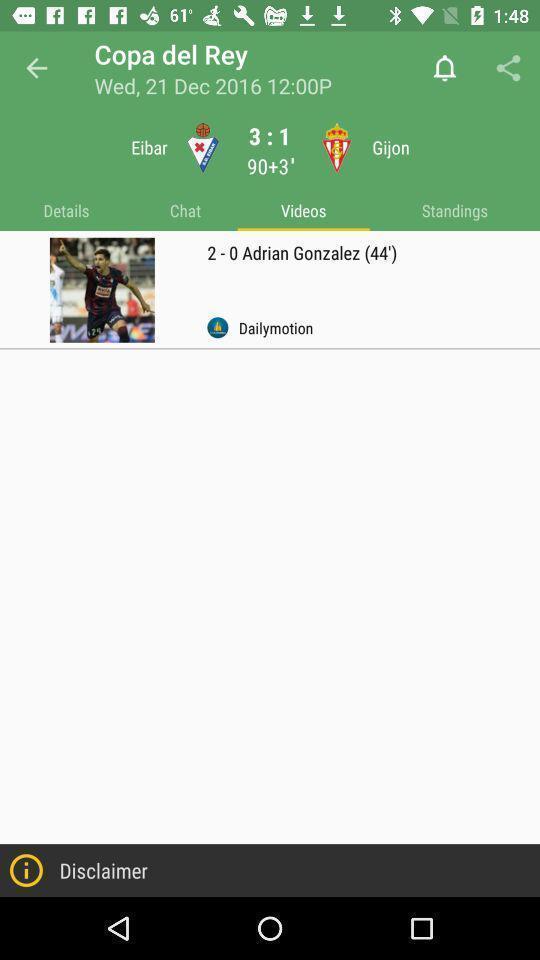Describe the visual elements of this screenshot. Videos page in a sports app. 